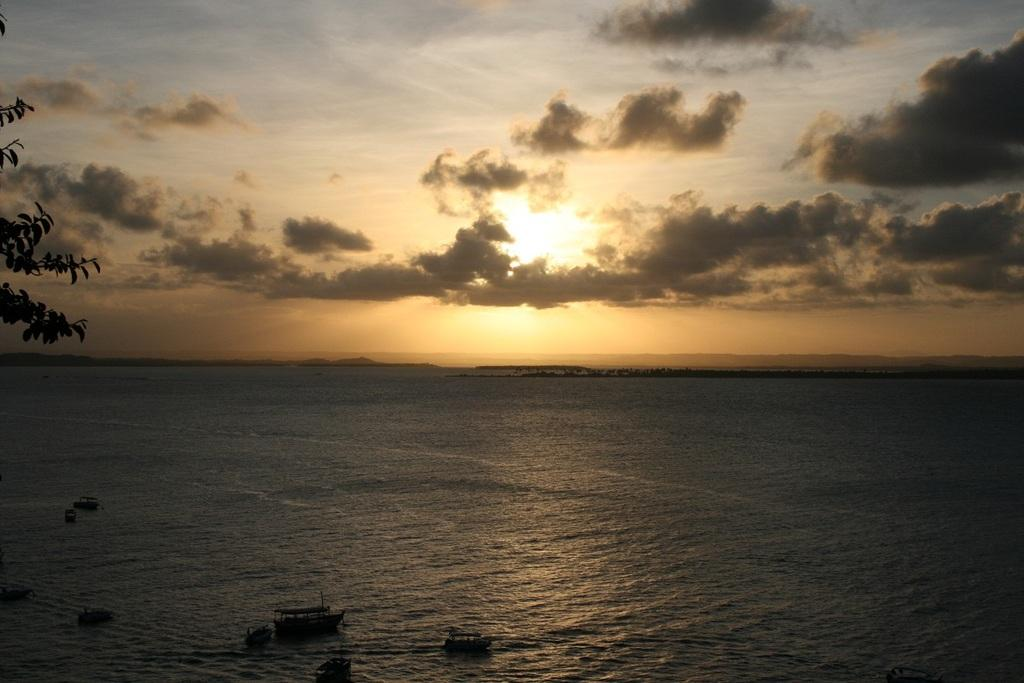What type of vehicles can be seen on the water in the image? There are boats on the water in the image. What can be seen on the left side of the image? There are branches of a plant on the left side of the image. What is visible in the background of the image? There are mountains and clouds in the sky in the background of the image. What type of food is being served on the mountain in the image? There is no food or mountain with food in the image; it features boats on the water, branches of a plant, mountains, and clouds in the sky. 